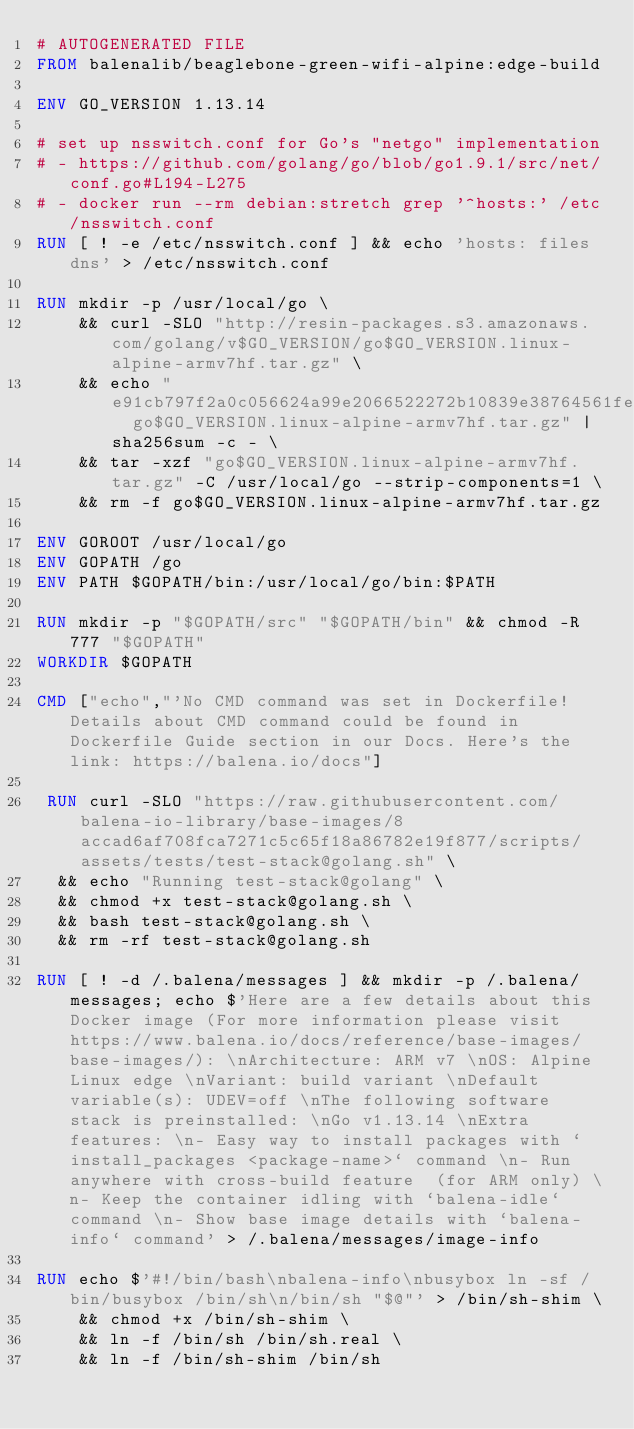Convert code to text. <code><loc_0><loc_0><loc_500><loc_500><_Dockerfile_># AUTOGENERATED FILE
FROM balenalib/beaglebone-green-wifi-alpine:edge-build

ENV GO_VERSION 1.13.14

# set up nsswitch.conf for Go's "netgo" implementation
# - https://github.com/golang/go/blob/go1.9.1/src/net/conf.go#L194-L275
# - docker run --rm debian:stretch grep '^hosts:' /etc/nsswitch.conf
RUN [ ! -e /etc/nsswitch.conf ] && echo 'hosts: files dns' > /etc/nsswitch.conf

RUN mkdir -p /usr/local/go \
	&& curl -SLO "http://resin-packages.s3.amazonaws.com/golang/v$GO_VERSION/go$GO_VERSION.linux-alpine-armv7hf.tar.gz" \
	&& echo "e91cb797f2a0c056624a99e2066522272b10839e38764561fed733434ddb6882  go$GO_VERSION.linux-alpine-armv7hf.tar.gz" | sha256sum -c - \
	&& tar -xzf "go$GO_VERSION.linux-alpine-armv7hf.tar.gz" -C /usr/local/go --strip-components=1 \
	&& rm -f go$GO_VERSION.linux-alpine-armv7hf.tar.gz

ENV GOROOT /usr/local/go
ENV GOPATH /go
ENV PATH $GOPATH/bin:/usr/local/go/bin:$PATH

RUN mkdir -p "$GOPATH/src" "$GOPATH/bin" && chmod -R 777 "$GOPATH"
WORKDIR $GOPATH

CMD ["echo","'No CMD command was set in Dockerfile! Details about CMD command could be found in Dockerfile Guide section in our Docs. Here's the link: https://balena.io/docs"]

 RUN curl -SLO "https://raw.githubusercontent.com/balena-io-library/base-images/8accad6af708fca7271c5c65f18a86782e19f877/scripts/assets/tests/test-stack@golang.sh" \
  && echo "Running test-stack@golang" \
  && chmod +x test-stack@golang.sh \
  && bash test-stack@golang.sh \
  && rm -rf test-stack@golang.sh 

RUN [ ! -d /.balena/messages ] && mkdir -p /.balena/messages; echo $'Here are a few details about this Docker image (For more information please visit https://www.balena.io/docs/reference/base-images/base-images/): \nArchitecture: ARM v7 \nOS: Alpine Linux edge \nVariant: build variant \nDefault variable(s): UDEV=off \nThe following software stack is preinstalled: \nGo v1.13.14 \nExtra features: \n- Easy way to install packages with `install_packages <package-name>` command \n- Run anywhere with cross-build feature  (for ARM only) \n- Keep the container idling with `balena-idle` command \n- Show base image details with `balena-info` command' > /.balena/messages/image-info

RUN echo $'#!/bin/bash\nbalena-info\nbusybox ln -sf /bin/busybox /bin/sh\n/bin/sh "$@"' > /bin/sh-shim \
	&& chmod +x /bin/sh-shim \
	&& ln -f /bin/sh /bin/sh.real \
	&& ln -f /bin/sh-shim /bin/sh</code> 